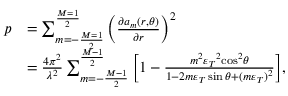Convert formula to latex. <formula><loc_0><loc_0><loc_500><loc_500>\begin{array} { r l } { p } & { = { \sum _ { m = - \frac { M = 1 } { 2 } } ^ { \frac { M = 1 } { 2 } } { \left ( { \frac { { \partial { a _ { m } } ( r , \theta ) } } { \partial r } } \right ) } ^ { 2 } } } \\ & { = \frac { { 4 { \pi ^ { 2 } } } } { { { \lambda ^ { 2 } } } } \sum _ { m = - \frac { M - 1 } { 2 } } ^ { \frac { M - 1 } { 2 } } { \left [ { 1 - \frac { { { m ^ { 2 } } { \varepsilon _ { T } } ^ { 2 } { { \cos } ^ { 2 } } \theta } } { { 1 - 2 m { \varepsilon _ { T } } \sin \theta + { { ( m { \varepsilon _ { T } } ) } ^ { 2 } } } } } \right ] } , } \end{array}</formula> 